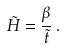Convert formula to latex. <formula><loc_0><loc_0><loc_500><loc_500>\tilde { H } = \frac { \beta } { \tilde { t } } \, .</formula> 